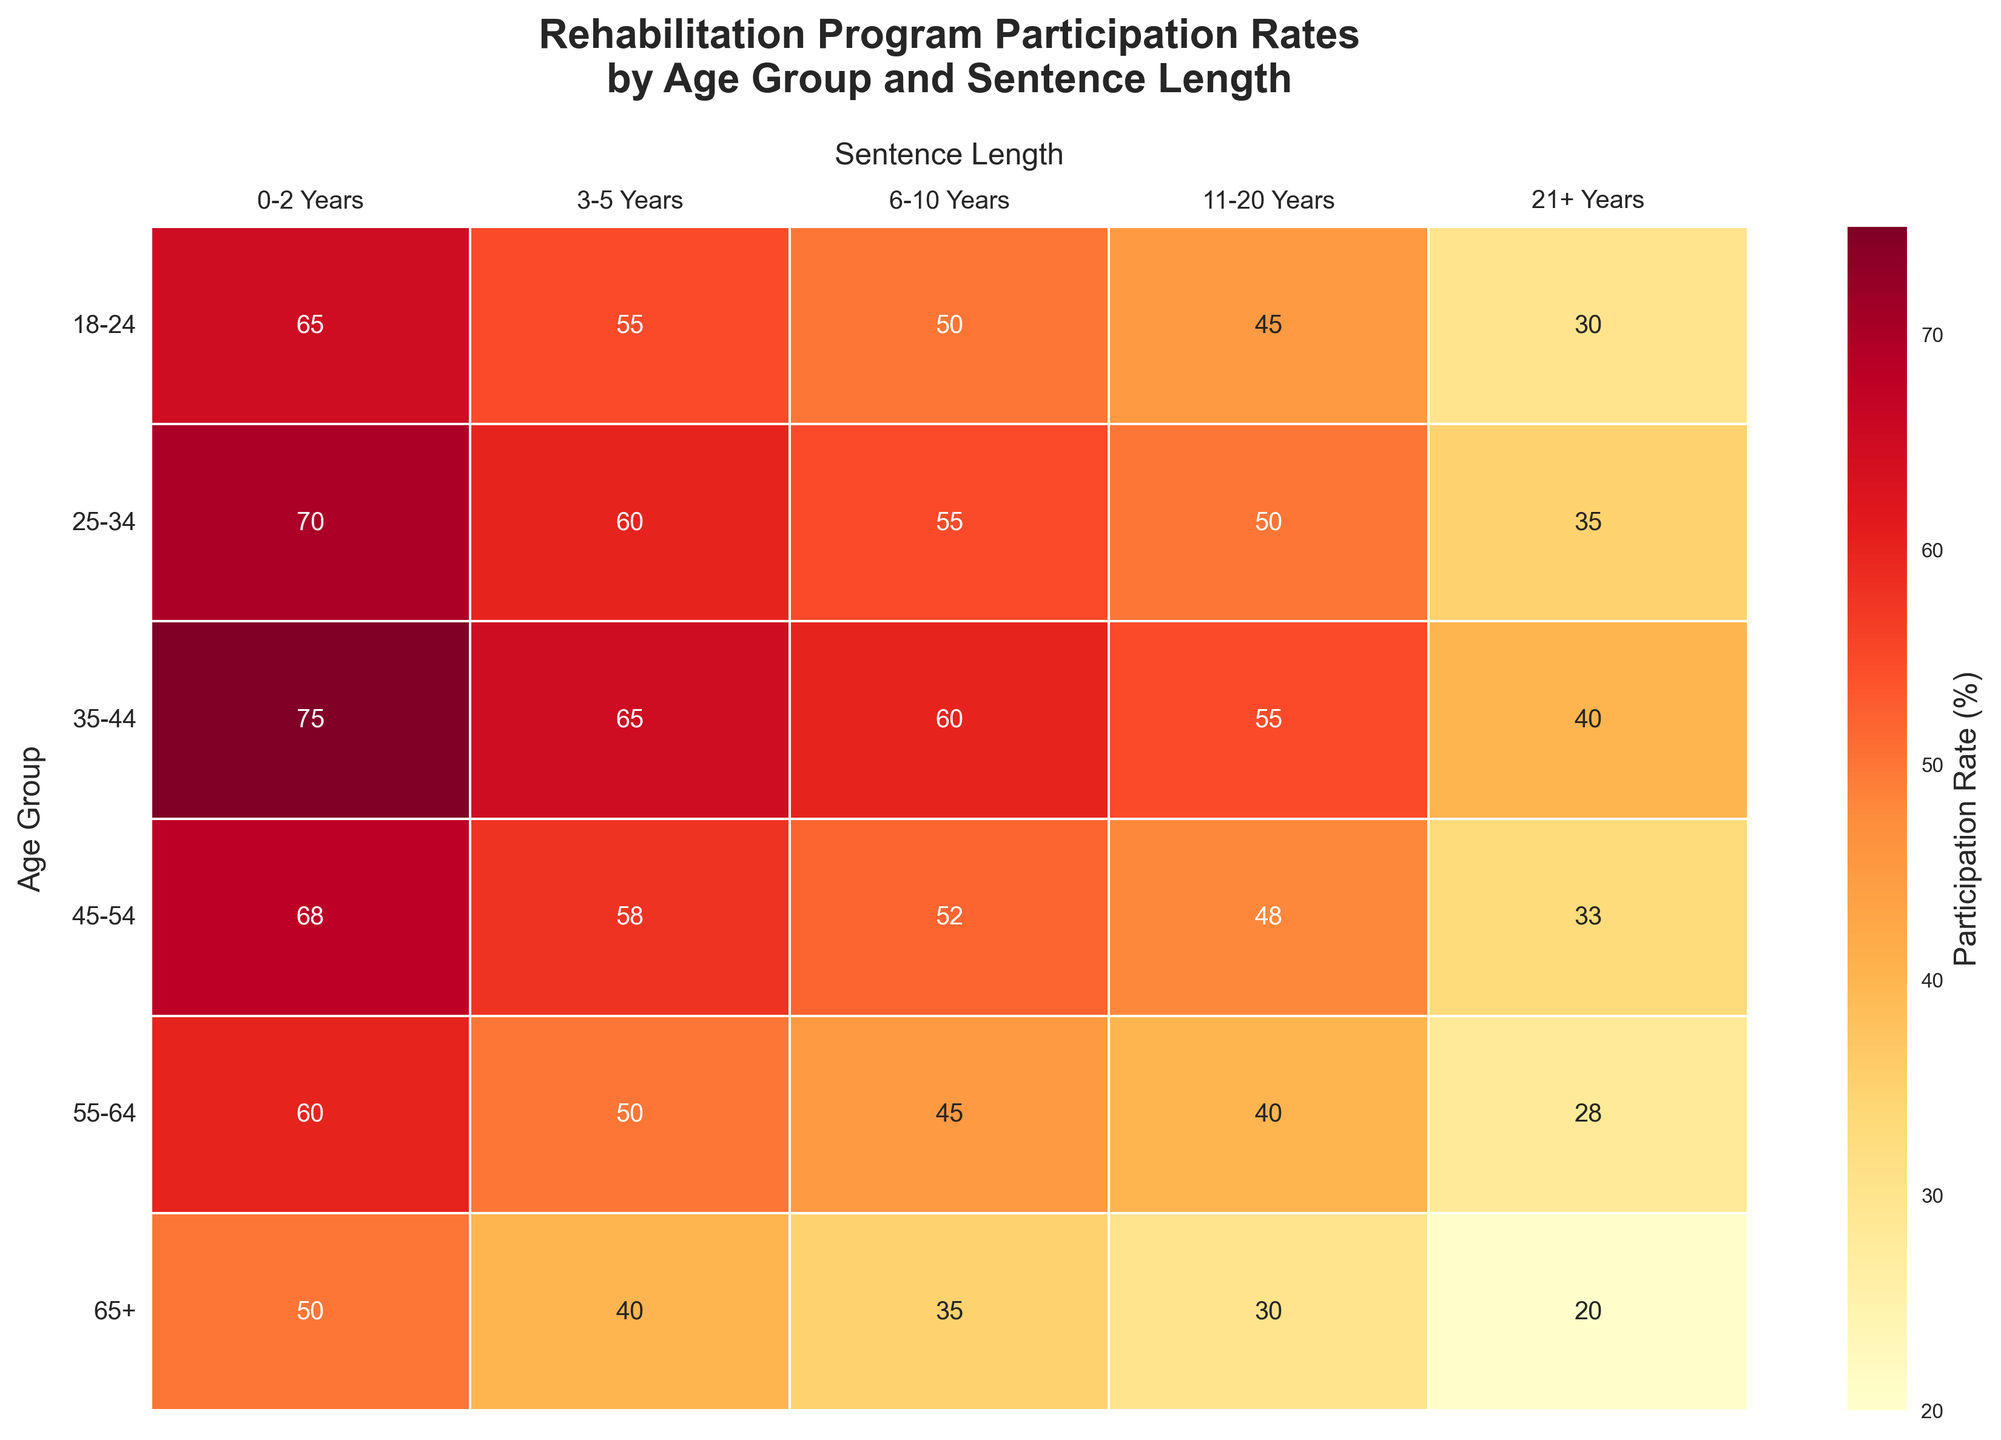What is the participation rate for the 18-24 age group with a sentence length of 6-10 years? Look at the intersection of the "18-24" age group row and the "6-10 Years" column, you will find the value 50.
Answer: 50% Which age group has the highest participation rate for sentence lengths of 3-5 years? Identify the highest value in the "3-5 Years" column and find the corresponding age group. The highest value is 65, which belongs to the 35-44 age group.
Answer: 35-44 What is the average participation rate for the 25-34 age group across all sentence lengths? Sum the values of the 25-34 age group row (70 + 60 + 55 + 50 + 35) which equals 270, and then divide by the number of values (5). 270 / 5 = 54.
Answer: 54 How does the participation rate for the 45-54 age group change as the sentence length increases? Look at the values in the row for the 45-54 age group: 68, 58, 52, 48, 33. The values decrease as the sentence length increases.
Answer: It decreases Which age group has the lowest participation rate for sentence lengths of 0-2 years? Identify the lowest value in the "0-2 Years" column and find the corresponding age group. The lowest value is 50, which belongs to the 65+ age group.
Answer: 65+ For the age group 35-44, what is the difference in participation rates between sentence lengths of 0-2 years and 21+ years? Subtract the participation rate for the 21+ years sentence length from the rate for the 0-2 years sentence length in the 35-44 age group: 75 - 40 = 35.
Answer: 35 What is the trend in participation rates for the 65+ age group across different sentence lengths? Examine the values in the row for the 65+ age group: 50, 40, 35, 30, 20. The values decrease as the sentence length increases.
Answer: It decreases Which sentence length group sees the highest participation rate across all age groups? Identify the highest value in the entire heatmap. The value is 75, which belongs to the "0-2 Years" sentence length for the 35-44 age group.
Answer: 0-2 Years Between the 25-34 and 55-64 age groups, which one has a higher average participation rate across all sentence lengths? Calculate the average for each group:
For 25-34: (70 + 60 + 55 + 50 + 35) / 5 = 54.
For 55-64: (60 + 50 + 45 + 40 + 28) / 5 = 44.6.
The 25-34 group has the higher average.
Answer: 25-34 Is there any age group where the participation rate is consistently decreasing with increasing sentence length? Analyze the participation rates for each age group across different sentence lengths and find a consistent decreasing pattern. The age groups 18-24, 25-34, 35-44, 45-54, 55-64, and 65+ all show consistently decreasing trends.
Answer: Yes, all age groups 